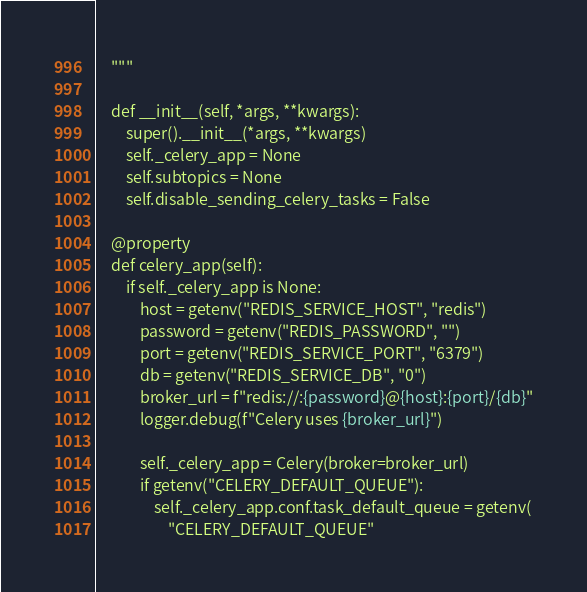<code> <loc_0><loc_0><loc_500><loc_500><_Python_>    """

    def __init__(self, *args, **kwargs):
        super().__init__(*args, **kwargs)
        self._celery_app = None
        self.subtopics = None
        self.disable_sending_celery_tasks = False

    @property
    def celery_app(self):
        if self._celery_app is None:
            host = getenv("REDIS_SERVICE_HOST", "redis")
            password = getenv("REDIS_PASSWORD", "")
            port = getenv("REDIS_SERVICE_PORT", "6379")
            db = getenv("REDIS_SERVICE_DB", "0")
            broker_url = f"redis://:{password}@{host}:{port}/{db}"
            logger.debug(f"Celery uses {broker_url}")

            self._celery_app = Celery(broker=broker_url)
            if getenv("CELERY_DEFAULT_QUEUE"):
                self._celery_app.conf.task_default_queue = getenv(
                    "CELERY_DEFAULT_QUEUE"</code> 